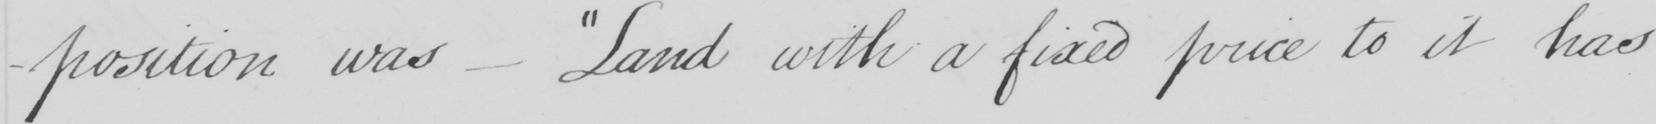What does this handwritten line say? -position was  _   " Land with a fixed price to it has 